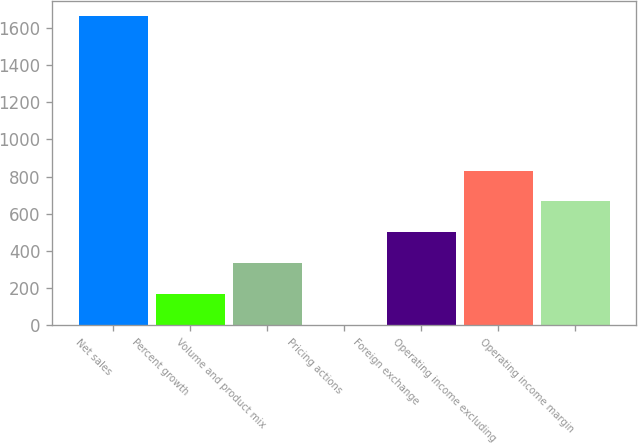Convert chart to OTSL. <chart><loc_0><loc_0><loc_500><loc_500><bar_chart><fcel>Net sales<fcel>Percent growth<fcel>Volume and product mix<fcel>Pricing actions<fcel>Foreign exchange<fcel>Operating income excluding<fcel>Operating income margin<nl><fcel>1661.1<fcel>168.45<fcel>334.3<fcel>2.6<fcel>500.15<fcel>831.85<fcel>666<nl></chart> 